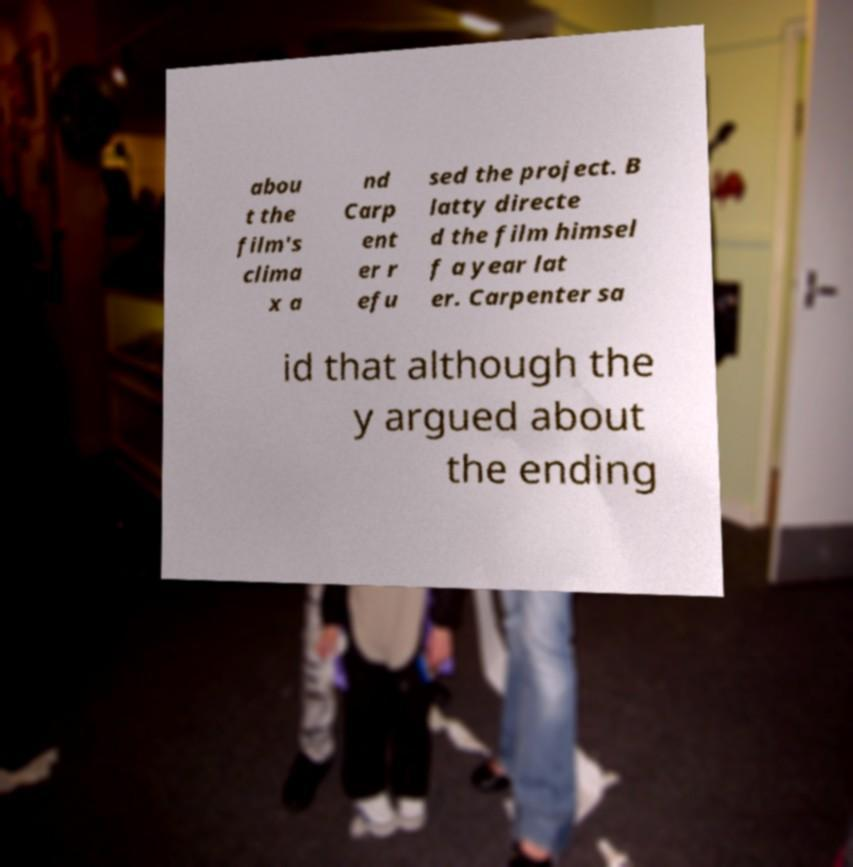Could you extract and type out the text from this image? abou t the film's clima x a nd Carp ent er r efu sed the project. B latty directe d the film himsel f a year lat er. Carpenter sa id that although the y argued about the ending 